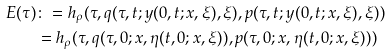Convert formula to latex. <formula><loc_0><loc_0><loc_500><loc_500>E ( \tau ) & \colon = h _ { \rho } ( \tau , q ( \tau , t ; y ( 0 , t ; x , \xi ) , \xi ) , p ( \tau , t ; y ( 0 , t ; x , \xi ) , \xi ) ) \\ & = h _ { \rho } ( \tau , q ( \tau , 0 ; x , \eta ( t , 0 ; x , \xi ) ) , p ( \tau , 0 ; x , \eta ( t , 0 ; x , \xi ) ) )</formula> 